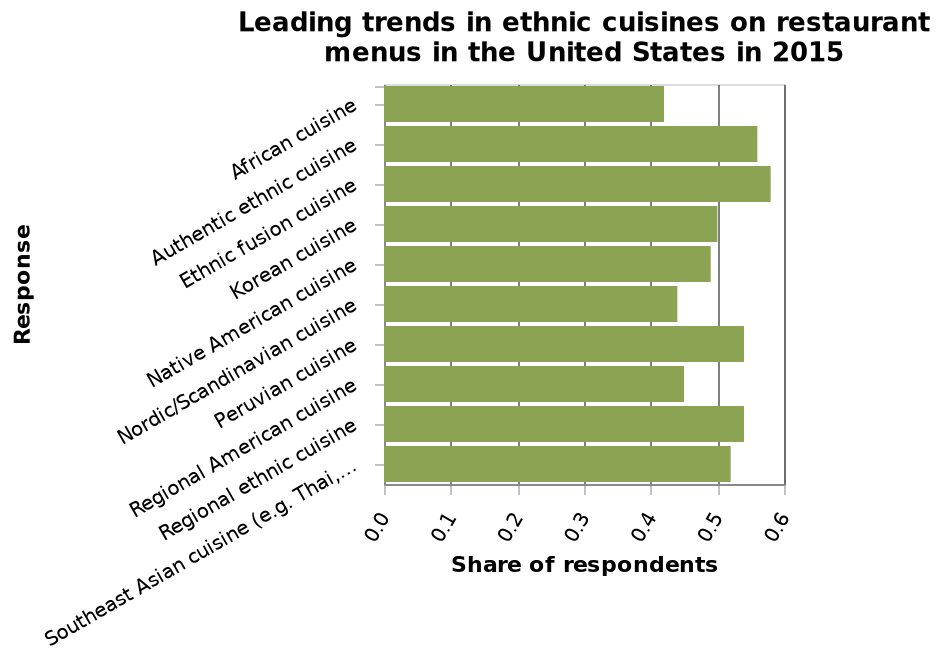<image>
Offer a thorough analysis of the image. peruvian, authentic and fusion ethnic food categories have the highest share of respondents, and african, nordic and regional ethnic cuisine with the lowest share. What type of cuisine has the highest share of respondents?  Peruvian, authentic and fusion ethnic food categories have the highest share of respondents. 